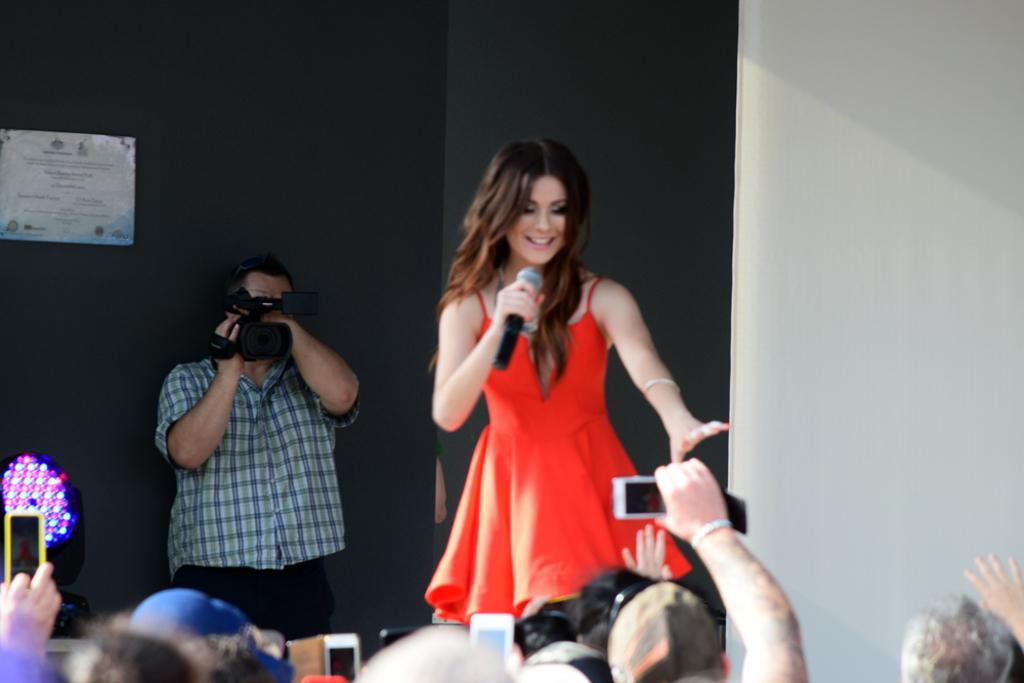Who is the main subject in the image? There is a woman in the image. What is the woman holding in the image? The woman is holding a microphone. What is the woman doing in the image? The woman is speaking. What are the people around the woman doing? People are taking pictures of the woman. What type of tray is the woman using to hold the microphone in the image? There is no tray present in the image; the woman is holding the microphone directly. 